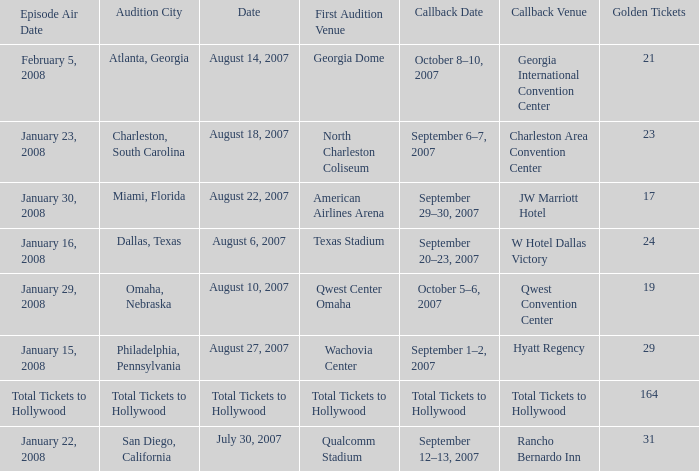What audition city has a Callback Date of october 5–6, 2007? Omaha, Nebraska. 